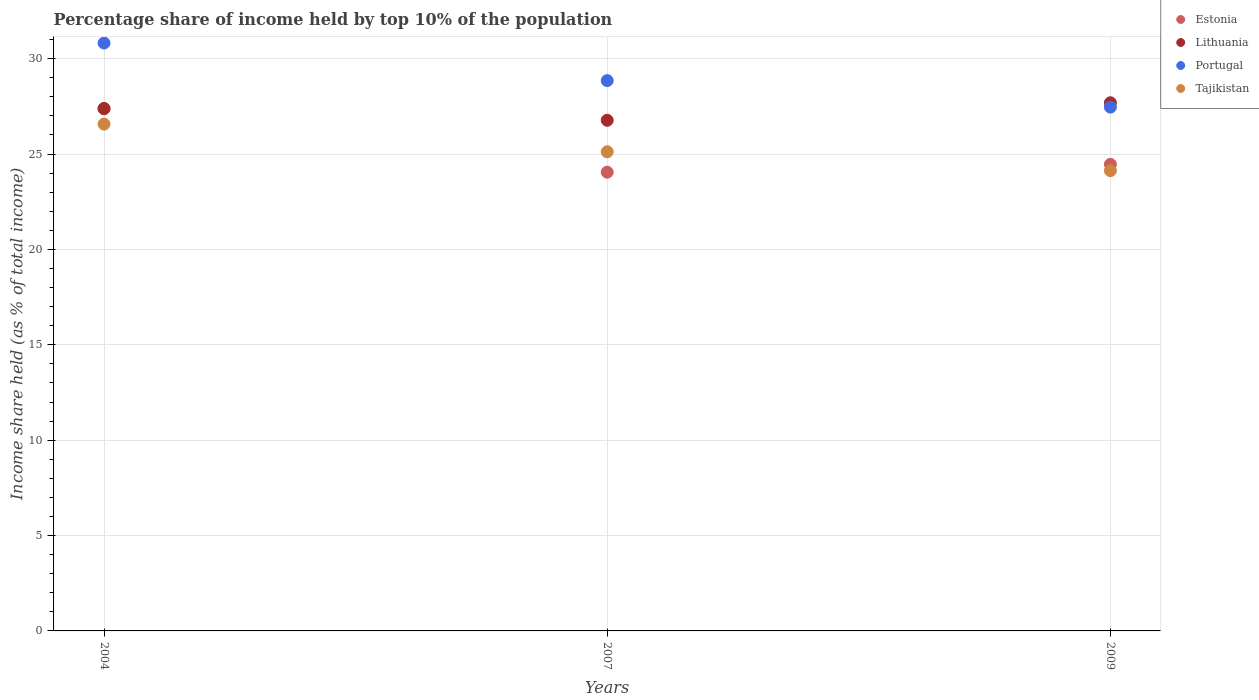How many different coloured dotlines are there?
Offer a terse response. 4. What is the percentage share of income held by top 10% of the population in Estonia in 2009?
Provide a succinct answer. 24.46. Across all years, what is the maximum percentage share of income held by top 10% of the population in Portugal?
Provide a succinct answer. 30.82. Across all years, what is the minimum percentage share of income held by top 10% of the population in Estonia?
Provide a succinct answer. 24.05. In which year was the percentage share of income held by top 10% of the population in Estonia minimum?
Your answer should be very brief. 2007. What is the total percentage share of income held by top 10% of the population in Lithuania in the graph?
Ensure brevity in your answer.  81.85. What is the difference between the percentage share of income held by top 10% of the population in Lithuania in 2007 and that in 2009?
Offer a terse response. -0.92. What is the difference between the percentage share of income held by top 10% of the population in Lithuania in 2004 and the percentage share of income held by top 10% of the population in Estonia in 2009?
Make the answer very short. 2.93. What is the average percentage share of income held by top 10% of the population in Estonia per year?
Your answer should be compact. 25.29. In how many years, is the percentage share of income held by top 10% of the population in Tajikistan greater than 21 %?
Make the answer very short. 3. What is the ratio of the percentage share of income held by top 10% of the population in Lithuania in 2004 to that in 2007?
Offer a terse response. 1.02. Is the percentage share of income held by top 10% of the population in Tajikistan in 2004 less than that in 2009?
Your answer should be very brief. No. Is the difference between the percentage share of income held by top 10% of the population in Estonia in 2004 and 2009 greater than the difference between the percentage share of income held by top 10% of the population in Portugal in 2004 and 2009?
Offer a terse response. No. What is the difference between the highest and the second highest percentage share of income held by top 10% of the population in Tajikistan?
Your answer should be very brief. 1.45. What is the difference between the highest and the lowest percentage share of income held by top 10% of the population in Tajikistan?
Give a very brief answer. 2.44. In how many years, is the percentage share of income held by top 10% of the population in Portugal greater than the average percentage share of income held by top 10% of the population in Portugal taken over all years?
Offer a terse response. 1. Does the percentage share of income held by top 10% of the population in Estonia monotonically increase over the years?
Offer a very short reply. No. Does the graph contain grids?
Provide a short and direct response. Yes. Where does the legend appear in the graph?
Provide a succinct answer. Top right. How many legend labels are there?
Provide a succinct answer. 4. How are the legend labels stacked?
Offer a terse response. Vertical. What is the title of the graph?
Give a very brief answer. Percentage share of income held by top 10% of the population. What is the label or title of the X-axis?
Ensure brevity in your answer.  Years. What is the label or title of the Y-axis?
Your answer should be very brief. Income share held (as % of total income). What is the Income share held (as % of total income) of Estonia in 2004?
Offer a very short reply. 27.37. What is the Income share held (as % of total income) of Lithuania in 2004?
Your answer should be very brief. 27.39. What is the Income share held (as % of total income) in Portugal in 2004?
Make the answer very short. 30.82. What is the Income share held (as % of total income) of Tajikistan in 2004?
Your response must be concise. 26.57. What is the Income share held (as % of total income) of Estonia in 2007?
Your answer should be very brief. 24.05. What is the Income share held (as % of total income) of Lithuania in 2007?
Make the answer very short. 26.77. What is the Income share held (as % of total income) of Portugal in 2007?
Provide a short and direct response. 28.85. What is the Income share held (as % of total income) in Tajikistan in 2007?
Give a very brief answer. 25.12. What is the Income share held (as % of total income) of Estonia in 2009?
Your answer should be very brief. 24.46. What is the Income share held (as % of total income) in Lithuania in 2009?
Offer a terse response. 27.69. What is the Income share held (as % of total income) in Portugal in 2009?
Keep it short and to the point. 27.46. What is the Income share held (as % of total income) of Tajikistan in 2009?
Provide a succinct answer. 24.13. Across all years, what is the maximum Income share held (as % of total income) of Estonia?
Your answer should be very brief. 27.37. Across all years, what is the maximum Income share held (as % of total income) in Lithuania?
Your answer should be compact. 27.69. Across all years, what is the maximum Income share held (as % of total income) in Portugal?
Give a very brief answer. 30.82. Across all years, what is the maximum Income share held (as % of total income) in Tajikistan?
Make the answer very short. 26.57. Across all years, what is the minimum Income share held (as % of total income) of Estonia?
Your answer should be compact. 24.05. Across all years, what is the minimum Income share held (as % of total income) of Lithuania?
Provide a short and direct response. 26.77. Across all years, what is the minimum Income share held (as % of total income) in Portugal?
Give a very brief answer. 27.46. Across all years, what is the minimum Income share held (as % of total income) of Tajikistan?
Keep it short and to the point. 24.13. What is the total Income share held (as % of total income) in Estonia in the graph?
Your response must be concise. 75.88. What is the total Income share held (as % of total income) of Lithuania in the graph?
Your answer should be compact. 81.85. What is the total Income share held (as % of total income) of Portugal in the graph?
Your response must be concise. 87.13. What is the total Income share held (as % of total income) in Tajikistan in the graph?
Provide a short and direct response. 75.82. What is the difference between the Income share held (as % of total income) of Estonia in 2004 and that in 2007?
Ensure brevity in your answer.  3.32. What is the difference between the Income share held (as % of total income) of Lithuania in 2004 and that in 2007?
Keep it short and to the point. 0.62. What is the difference between the Income share held (as % of total income) of Portugal in 2004 and that in 2007?
Your response must be concise. 1.97. What is the difference between the Income share held (as % of total income) in Tajikistan in 2004 and that in 2007?
Give a very brief answer. 1.45. What is the difference between the Income share held (as % of total income) in Estonia in 2004 and that in 2009?
Your answer should be compact. 2.91. What is the difference between the Income share held (as % of total income) of Portugal in 2004 and that in 2009?
Offer a terse response. 3.36. What is the difference between the Income share held (as % of total income) of Tajikistan in 2004 and that in 2009?
Provide a succinct answer. 2.44. What is the difference between the Income share held (as % of total income) of Estonia in 2007 and that in 2009?
Your response must be concise. -0.41. What is the difference between the Income share held (as % of total income) of Lithuania in 2007 and that in 2009?
Provide a succinct answer. -0.92. What is the difference between the Income share held (as % of total income) of Portugal in 2007 and that in 2009?
Make the answer very short. 1.39. What is the difference between the Income share held (as % of total income) in Tajikistan in 2007 and that in 2009?
Make the answer very short. 0.99. What is the difference between the Income share held (as % of total income) of Estonia in 2004 and the Income share held (as % of total income) of Lithuania in 2007?
Keep it short and to the point. 0.6. What is the difference between the Income share held (as % of total income) of Estonia in 2004 and the Income share held (as % of total income) of Portugal in 2007?
Offer a terse response. -1.48. What is the difference between the Income share held (as % of total income) in Estonia in 2004 and the Income share held (as % of total income) in Tajikistan in 2007?
Offer a very short reply. 2.25. What is the difference between the Income share held (as % of total income) of Lithuania in 2004 and the Income share held (as % of total income) of Portugal in 2007?
Your answer should be compact. -1.46. What is the difference between the Income share held (as % of total income) of Lithuania in 2004 and the Income share held (as % of total income) of Tajikistan in 2007?
Your answer should be very brief. 2.27. What is the difference between the Income share held (as % of total income) in Estonia in 2004 and the Income share held (as % of total income) in Lithuania in 2009?
Ensure brevity in your answer.  -0.32. What is the difference between the Income share held (as % of total income) of Estonia in 2004 and the Income share held (as % of total income) of Portugal in 2009?
Ensure brevity in your answer.  -0.09. What is the difference between the Income share held (as % of total income) in Estonia in 2004 and the Income share held (as % of total income) in Tajikistan in 2009?
Provide a succinct answer. 3.24. What is the difference between the Income share held (as % of total income) of Lithuania in 2004 and the Income share held (as % of total income) of Portugal in 2009?
Keep it short and to the point. -0.07. What is the difference between the Income share held (as % of total income) in Lithuania in 2004 and the Income share held (as % of total income) in Tajikistan in 2009?
Ensure brevity in your answer.  3.26. What is the difference between the Income share held (as % of total income) in Portugal in 2004 and the Income share held (as % of total income) in Tajikistan in 2009?
Make the answer very short. 6.69. What is the difference between the Income share held (as % of total income) of Estonia in 2007 and the Income share held (as % of total income) of Lithuania in 2009?
Make the answer very short. -3.64. What is the difference between the Income share held (as % of total income) of Estonia in 2007 and the Income share held (as % of total income) of Portugal in 2009?
Offer a terse response. -3.41. What is the difference between the Income share held (as % of total income) in Estonia in 2007 and the Income share held (as % of total income) in Tajikistan in 2009?
Provide a short and direct response. -0.08. What is the difference between the Income share held (as % of total income) of Lithuania in 2007 and the Income share held (as % of total income) of Portugal in 2009?
Offer a very short reply. -0.69. What is the difference between the Income share held (as % of total income) of Lithuania in 2007 and the Income share held (as % of total income) of Tajikistan in 2009?
Your answer should be compact. 2.64. What is the difference between the Income share held (as % of total income) of Portugal in 2007 and the Income share held (as % of total income) of Tajikistan in 2009?
Your answer should be very brief. 4.72. What is the average Income share held (as % of total income) in Estonia per year?
Keep it short and to the point. 25.29. What is the average Income share held (as % of total income) in Lithuania per year?
Keep it short and to the point. 27.28. What is the average Income share held (as % of total income) of Portugal per year?
Provide a short and direct response. 29.04. What is the average Income share held (as % of total income) of Tajikistan per year?
Your answer should be compact. 25.27. In the year 2004, what is the difference between the Income share held (as % of total income) of Estonia and Income share held (as % of total income) of Lithuania?
Give a very brief answer. -0.02. In the year 2004, what is the difference between the Income share held (as % of total income) in Estonia and Income share held (as % of total income) in Portugal?
Provide a succinct answer. -3.45. In the year 2004, what is the difference between the Income share held (as % of total income) in Estonia and Income share held (as % of total income) in Tajikistan?
Make the answer very short. 0.8. In the year 2004, what is the difference between the Income share held (as % of total income) of Lithuania and Income share held (as % of total income) of Portugal?
Your answer should be very brief. -3.43. In the year 2004, what is the difference between the Income share held (as % of total income) of Lithuania and Income share held (as % of total income) of Tajikistan?
Your answer should be very brief. 0.82. In the year 2004, what is the difference between the Income share held (as % of total income) in Portugal and Income share held (as % of total income) in Tajikistan?
Your answer should be very brief. 4.25. In the year 2007, what is the difference between the Income share held (as % of total income) of Estonia and Income share held (as % of total income) of Lithuania?
Give a very brief answer. -2.72. In the year 2007, what is the difference between the Income share held (as % of total income) in Estonia and Income share held (as % of total income) in Portugal?
Give a very brief answer. -4.8. In the year 2007, what is the difference between the Income share held (as % of total income) in Estonia and Income share held (as % of total income) in Tajikistan?
Give a very brief answer. -1.07. In the year 2007, what is the difference between the Income share held (as % of total income) of Lithuania and Income share held (as % of total income) of Portugal?
Offer a terse response. -2.08. In the year 2007, what is the difference between the Income share held (as % of total income) of Lithuania and Income share held (as % of total income) of Tajikistan?
Your answer should be very brief. 1.65. In the year 2007, what is the difference between the Income share held (as % of total income) of Portugal and Income share held (as % of total income) of Tajikistan?
Your answer should be very brief. 3.73. In the year 2009, what is the difference between the Income share held (as % of total income) of Estonia and Income share held (as % of total income) of Lithuania?
Keep it short and to the point. -3.23. In the year 2009, what is the difference between the Income share held (as % of total income) in Estonia and Income share held (as % of total income) in Portugal?
Keep it short and to the point. -3. In the year 2009, what is the difference between the Income share held (as % of total income) of Estonia and Income share held (as % of total income) of Tajikistan?
Make the answer very short. 0.33. In the year 2009, what is the difference between the Income share held (as % of total income) in Lithuania and Income share held (as % of total income) in Portugal?
Your answer should be compact. 0.23. In the year 2009, what is the difference between the Income share held (as % of total income) of Lithuania and Income share held (as % of total income) of Tajikistan?
Your answer should be very brief. 3.56. In the year 2009, what is the difference between the Income share held (as % of total income) in Portugal and Income share held (as % of total income) in Tajikistan?
Make the answer very short. 3.33. What is the ratio of the Income share held (as % of total income) of Estonia in 2004 to that in 2007?
Offer a very short reply. 1.14. What is the ratio of the Income share held (as % of total income) in Lithuania in 2004 to that in 2007?
Make the answer very short. 1.02. What is the ratio of the Income share held (as % of total income) in Portugal in 2004 to that in 2007?
Provide a succinct answer. 1.07. What is the ratio of the Income share held (as % of total income) in Tajikistan in 2004 to that in 2007?
Your answer should be compact. 1.06. What is the ratio of the Income share held (as % of total income) in Estonia in 2004 to that in 2009?
Keep it short and to the point. 1.12. What is the ratio of the Income share held (as % of total income) in Lithuania in 2004 to that in 2009?
Provide a short and direct response. 0.99. What is the ratio of the Income share held (as % of total income) in Portugal in 2004 to that in 2009?
Your answer should be compact. 1.12. What is the ratio of the Income share held (as % of total income) in Tajikistan in 2004 to that in 2009?
Provide a succinct answer. 1.1. What is the ratio of the Income share held (as % of total income) of Estonia in 2007 to that in 2009?
Ensure brevity in your answer.  0.98. What is the ratio of the Income share held (as % of total income) of Lithuania in 2007 to that in 2009?
Your answer should be compact. 0.97. What is the ratio of the Income share held (as % of total income) of Portugal in 2007 to that in 2009?
Keep it short and to the point. 1.05. What is the ratio of the Income share held (as % of total income) in Tajikistan in 2007 to that in 2009?
Offer a very short reply. 1.04. What is the difference between the highest and the second highest Income share held (as % of total income) of Estonia?
Your response must be concise. 2.91. What is the difference between the highest and the second highest Income share held (as % of total income) of Portugal?
Offer a terse response. 1.97. What is the difference between the highest and the second highest Income share held (as % of total income) of Tajikistan?
Ensure brevity in your answer.  1.45. What is the difference between the highest and the lowest Income share held (as % of total income) in Estonia?
Offer a terse response. 3.32. What is the difference between the highest and the lowest Income share held (as % of total income) in Portugal?
Keep it short and to the point. 3.36. What is the difference between the highest and the lowest Income share held (as % of total income) in Tajikistan?
Your answer should be very brief. 2.44. 